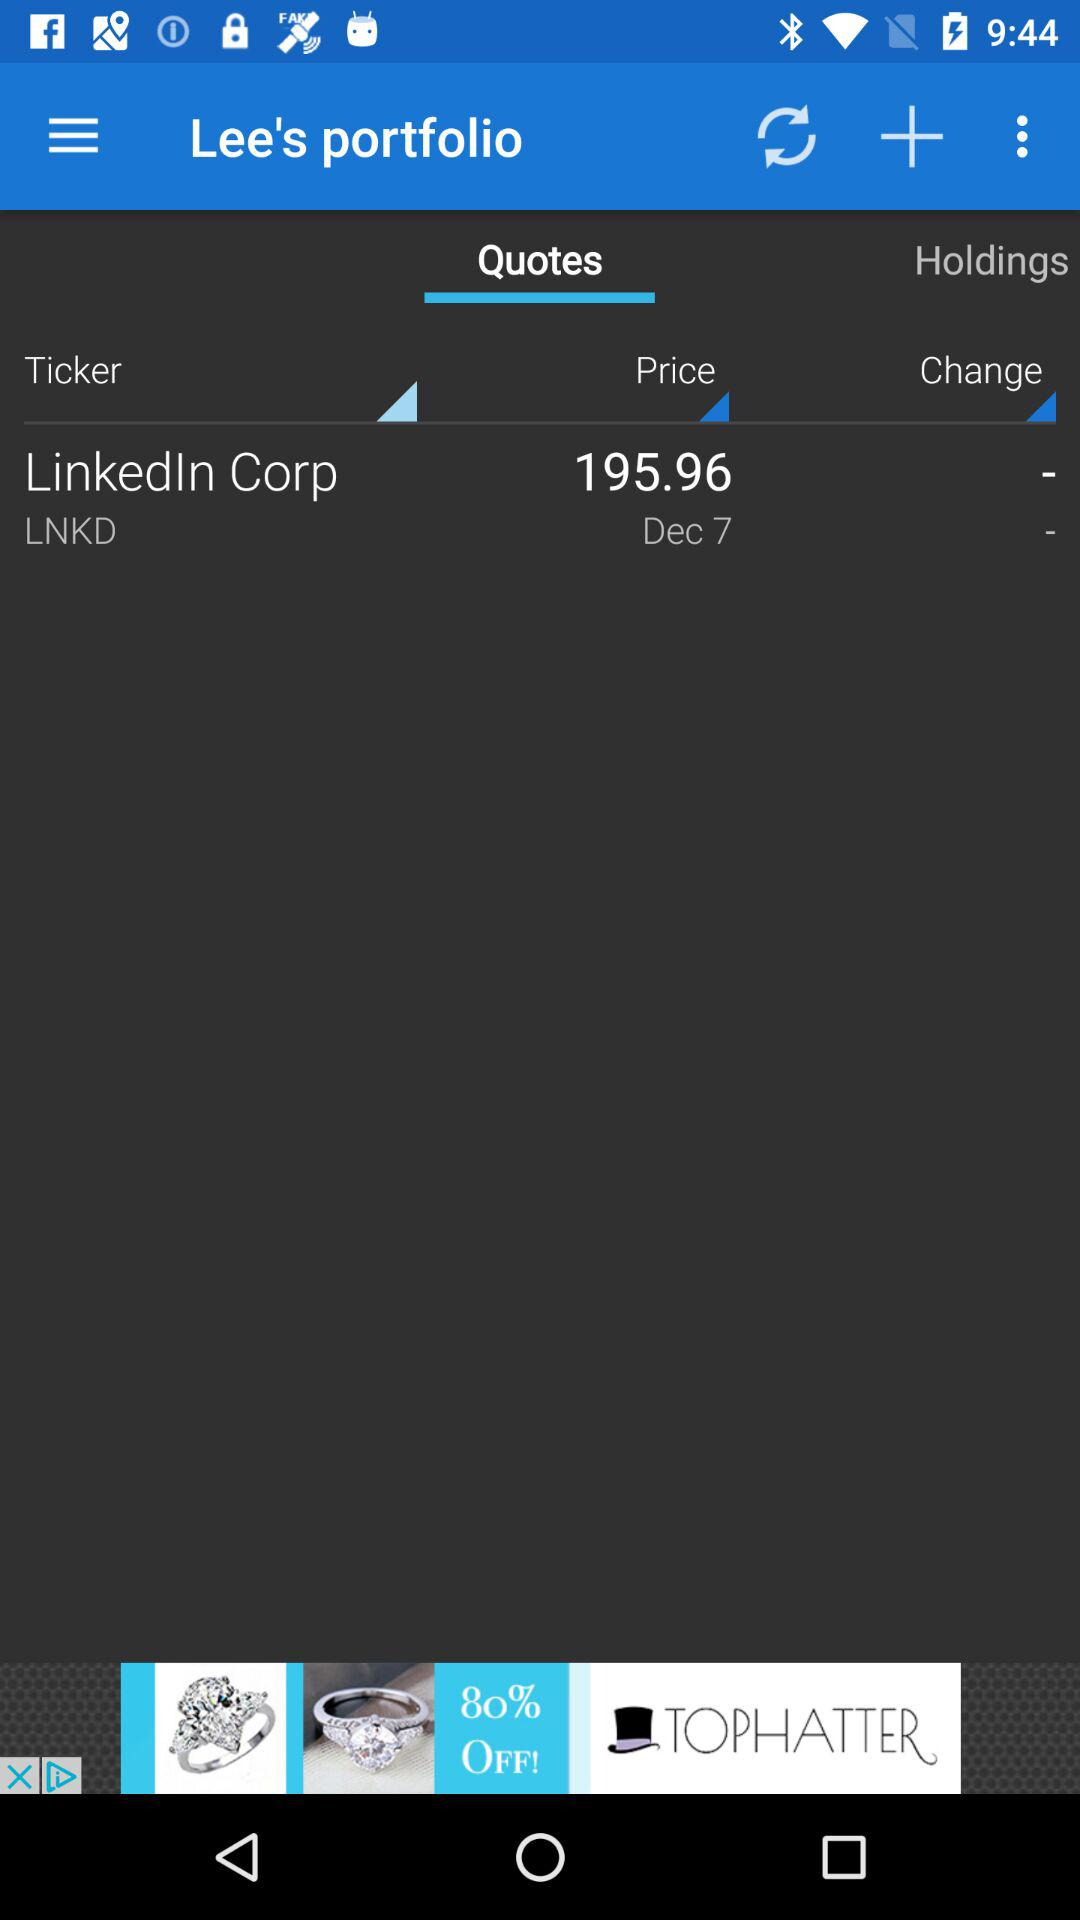Who's portfolio is this? This is Lee's portfolio. 